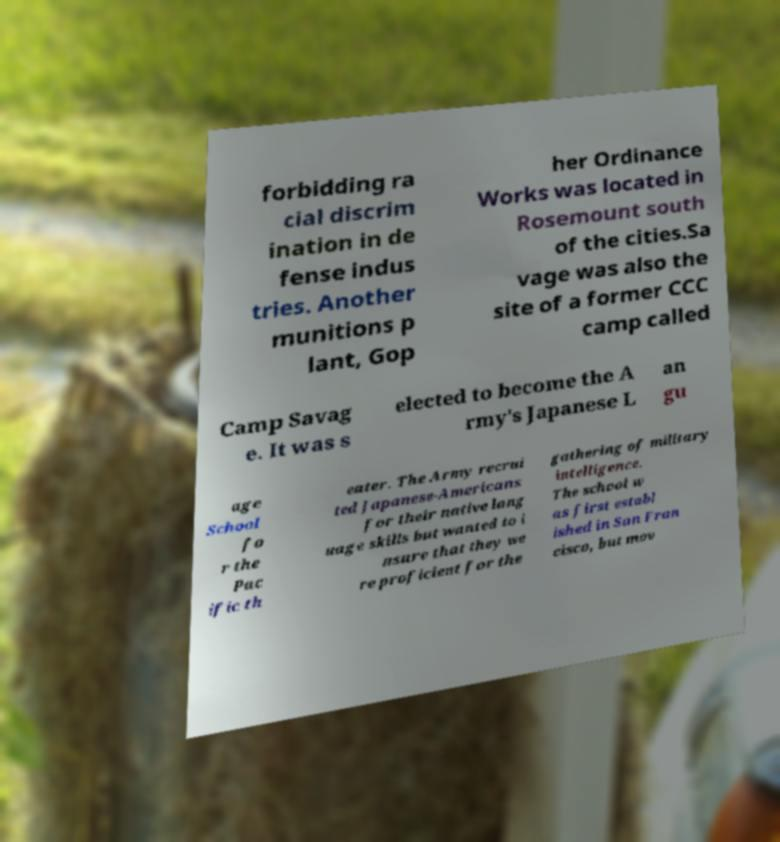There's text embedded in this image that I need extracted. Can you transcribe it verbatim? forbidding ra cial discrim ination in de fense indus tries. Another munitions p lant, Gop her Ordinance Works was located in Rosemount south of the cities.Sa vage was also the site of a former CCC camp called Camp Savag e. It was s elected to become the A rmy's Japanese L an gu age School fo r the Pac ific th eater. The Army recrui ted Japanese-Americans for their native lang uage skills but wanted to i nsure that they we re proficient for the gathering of military intelligence. The school w as first establ ished in San Fran cisco, but mov 